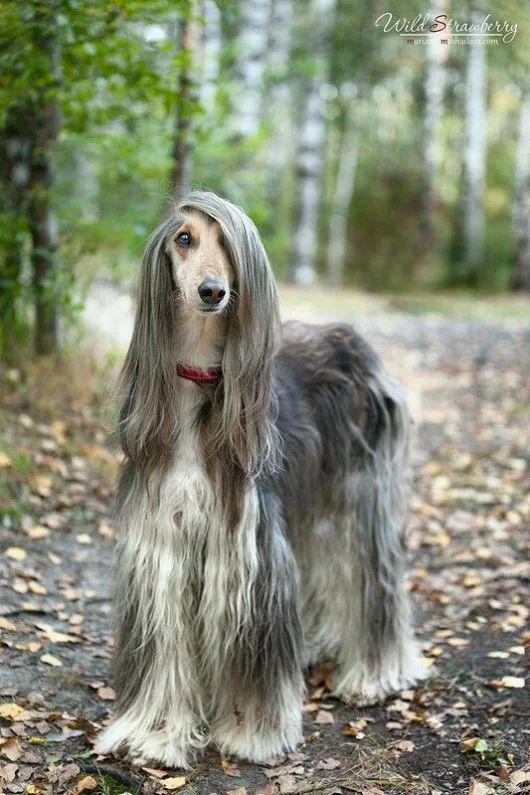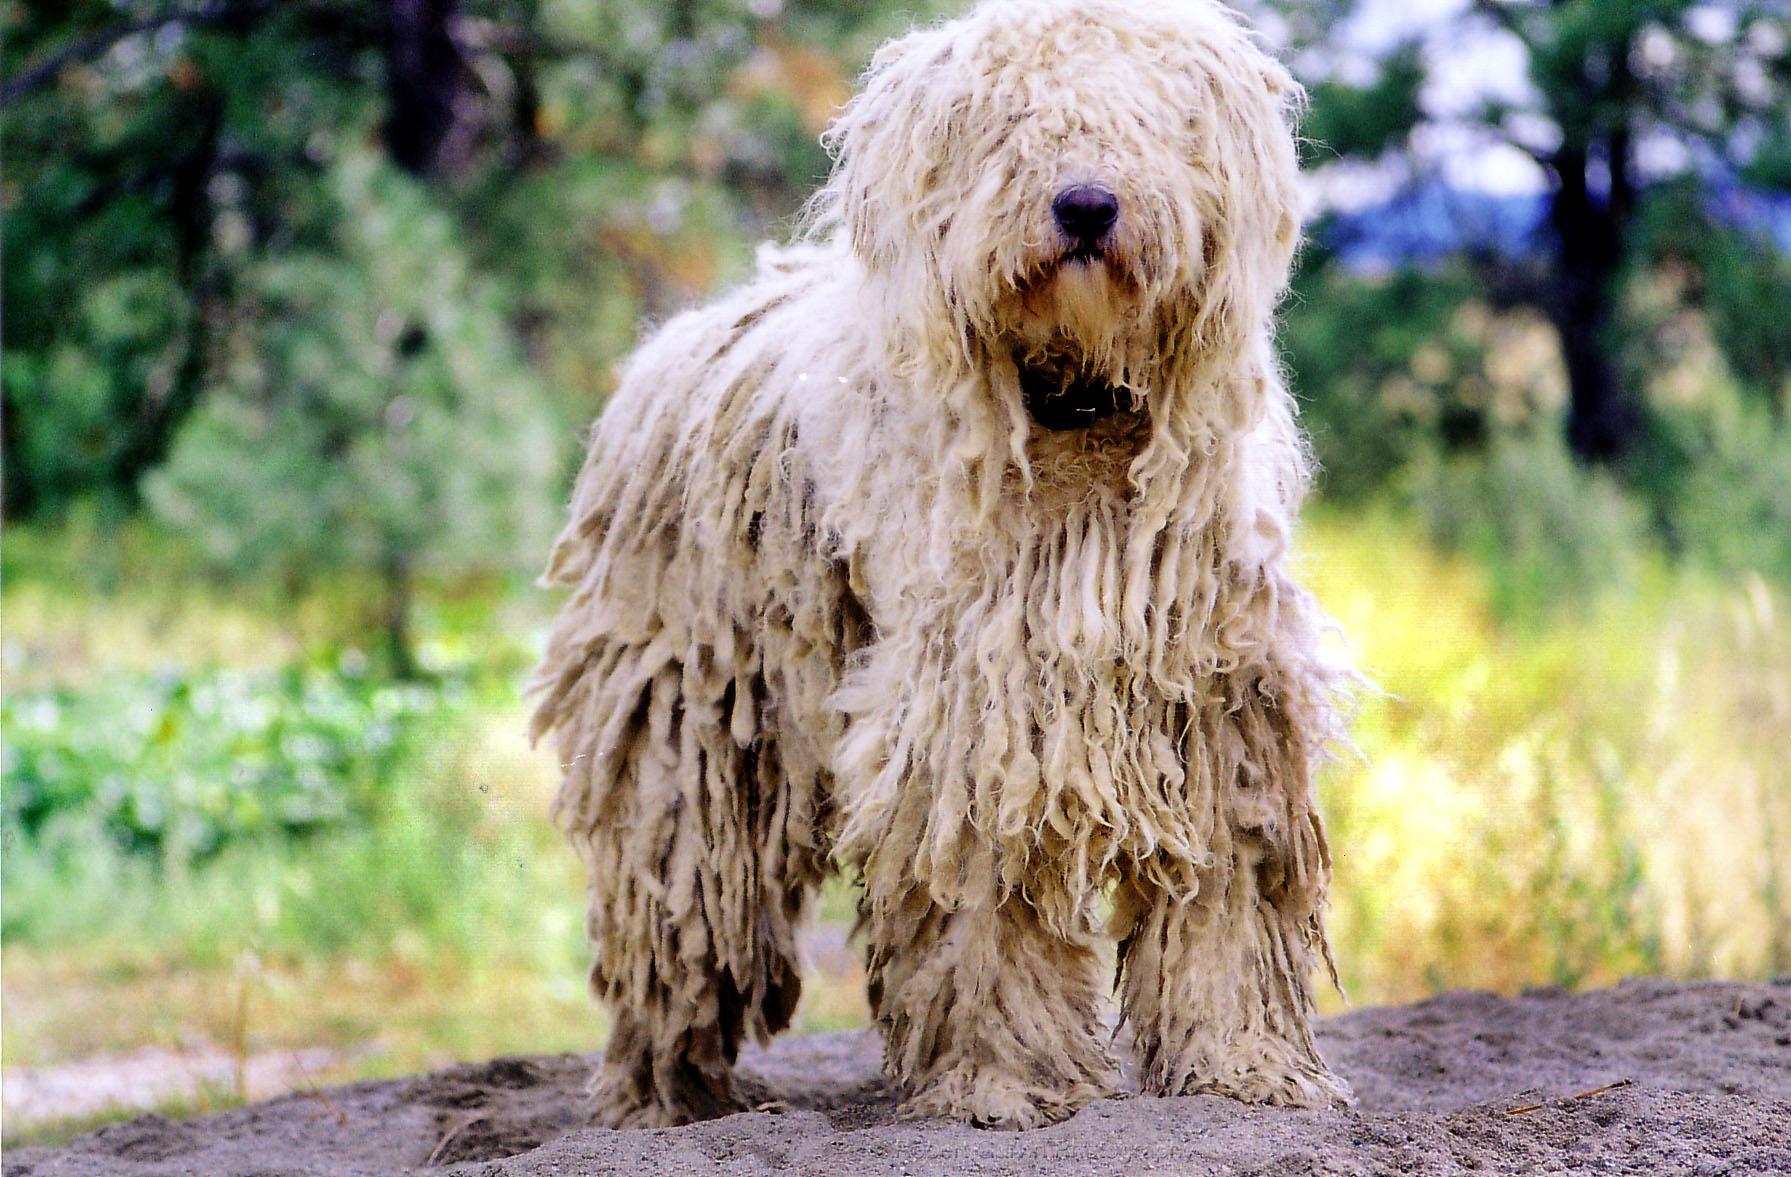The first image is the image on the left, the second image is the image on the right. For the images shown, is this caption "Only the dog in the left image is standing on all fours." true? Answer yes or no. No. 